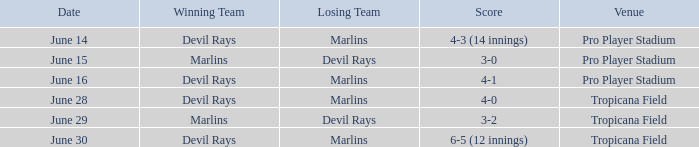On june 29, when the devil rays were defeated, what was the score? 3-2. 